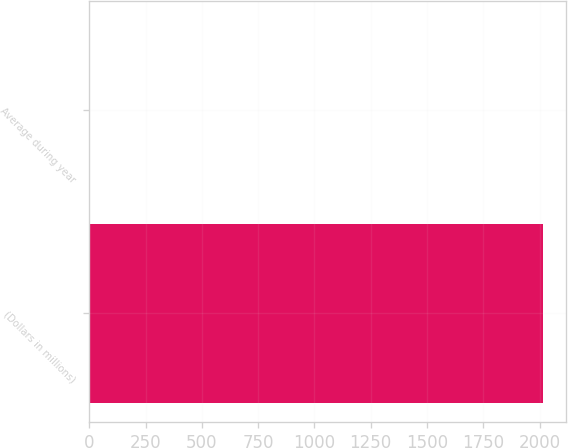Convert chart to OTSL. <chart><loc_0><loc_0><loc_500><loc_500><bar_chart><fcel>(Dollars in millions)<fcel>Average during year<nl><fcel>2016<fcel>0.52<nl></chart> 